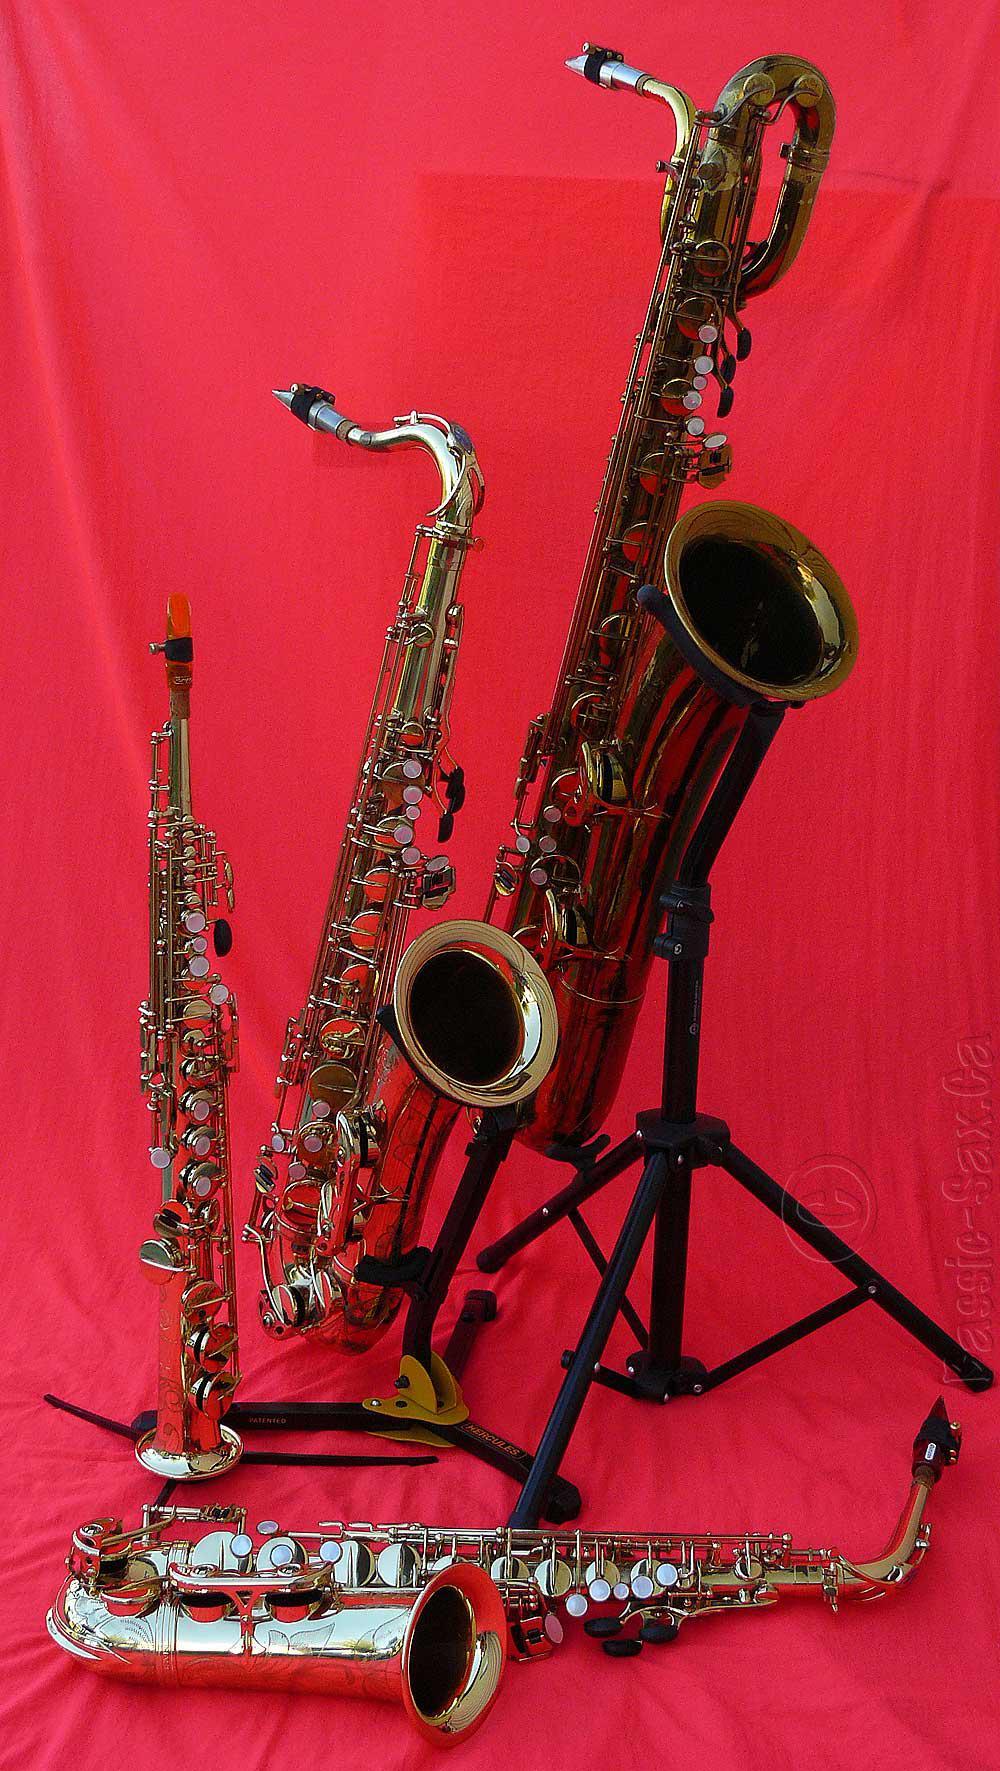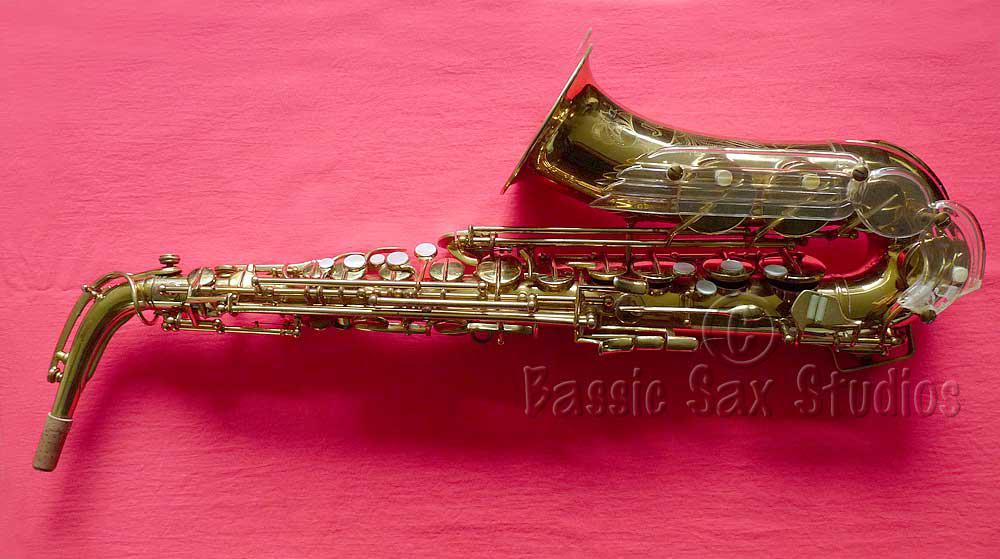The first image is the image on the left, the second image is the image on the right. Analyze the images presented: Is the assertion "The saxophones are positioned in the same way on the red blanket." valid? Answer yes or no. No. The first image is the image on the left, the second image is the image on the right. Given the left and right images, does the statement "Saxophones displayed in the left and right images are positioned in the same way and facing same direction." hold true? Answer yes or no. No. 